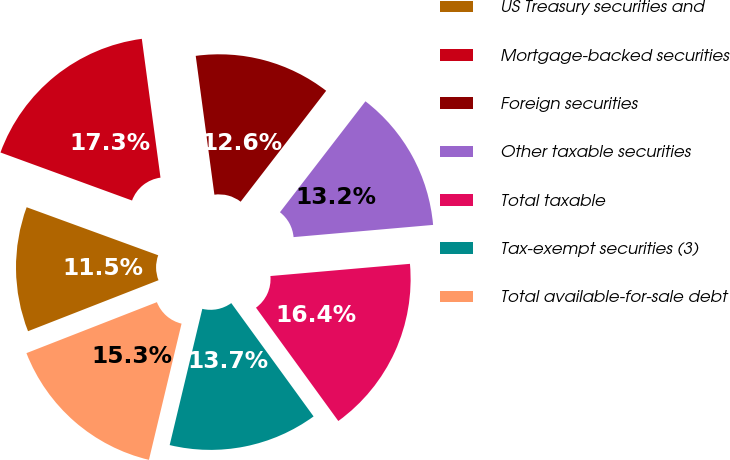<chart> <loc_0><loc_0><loc_500><loc_500><pie_chart><fcel>US Treasury securities and<fcel>Mortgage-backed securities<fcel>Foreign securities<fcel>Other taxable securities<fcel>Total taxable<fcel>Tax-exempt securities (3)<fcel>Total available-for-sale debt<nl><fcel>11.5%<fcel>17.3%<fcel>12.58%<fcel>13.16%<fcel>16.39%<fcel>13.74%<fcel>15.33%<nl></chart> 